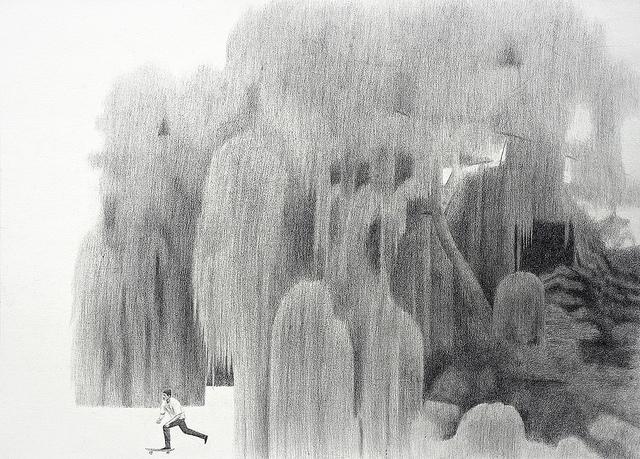Is this real?
Short answer required. No. What is the common name for the tree in this picture?
Give a very brief answer. Weeping willow. What is the man doing?
Answer briefly. Skateboarding. 